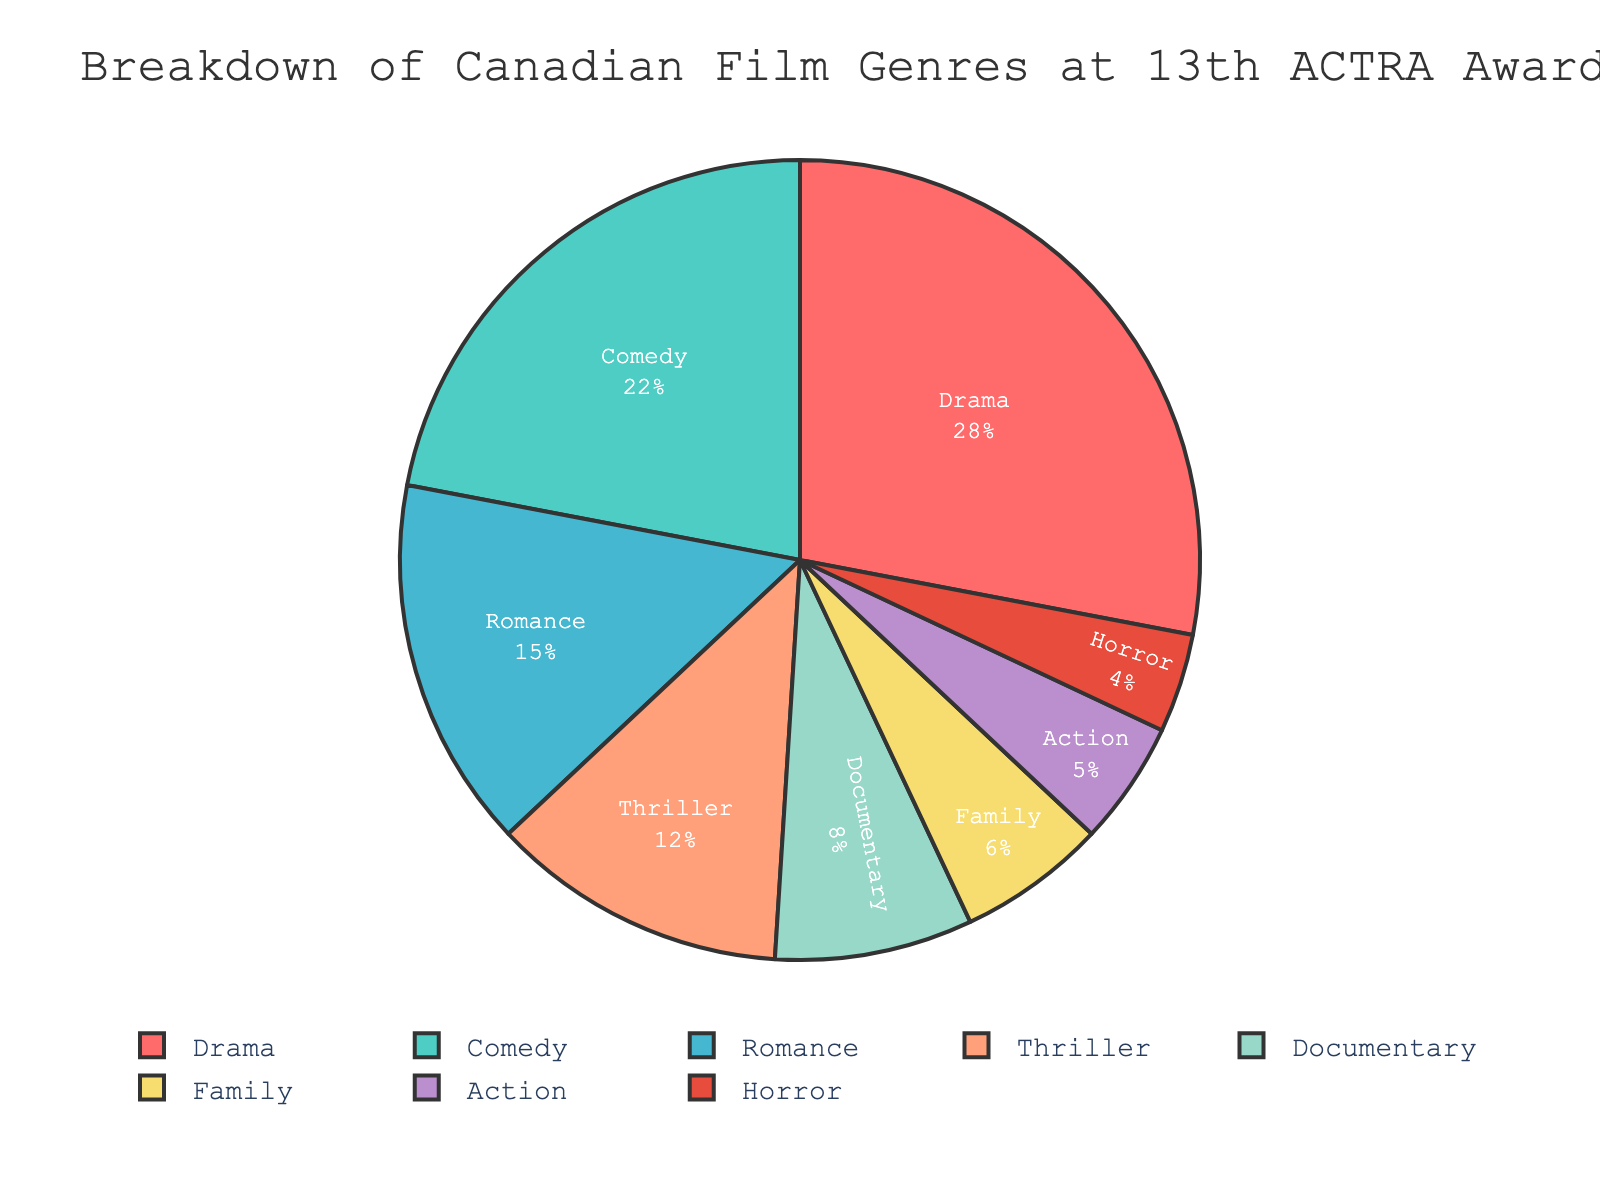Which genre has the largest percentage of Canadian films at the 13th ACTRA Awards? The genre with the largest segment in the pie chart represents the highest percentage. Comparing each segment, Drama occupies the largest space.
Answer: Drama Which genre has a smaller percentage, Family or Action? By comparing the size of the two segments, Action has a 5% share, while Family has a 6% share. Therefore, Action is smaller.
Answer: Action What is the combined percentage of Comedy, Romance, and Thriller genres? Sum the percentages of Comedy (22%), Romance (15%), and Thriller (12%): 22% + 15% + 12% = 49%.
Answer: 49% How many genres have a percentage greater than 10%? Identify and count the genres with a percentage greater than 10%: Drama (28%), Comedy (22%), Romance (15%), Thriller (12%). There are four genres.
Answer: Four Which color represents the Documentary genre in the pie chart? Based on the custom color palette: Red, Teal, Light Blue, Coral, Light Green, Light Yellow, Purple, Red. Documentary is the fifth genre listed, corresponding to Light Green.
Answer: Light Green Is the percentage of Horror films more than half of the percentage of Romance films? Half of Romance's percentage (15%) is 15%/2 = 7.5%. Horror has a percentage of 4%, which is less than 7.5%.
Answer: No What is the difference in percentage between Drama and Comedy genres? Subtract the percentage of Comedy (22%) from Drama (28%): 28% - 22% = 6%.
Answer: 6% Which genre has the smallest percentage, and what is its value? Identify the smallest segment, which represents Horror at 4%.
Answer: Horror, 4% What proportion of the total pie is occupied by Documentary and Family genres combined? Sum the percentages of Documentary (8%) and Family (6%): 8% + 6% = 14%.
Answer: 14% Which genres have a percentage less than or equal to 6%? Identify the genres with percentages less than or equal to 6%: Family (6%), Action (5%), Horror (4%).
Answer: Family, Action, Horror 